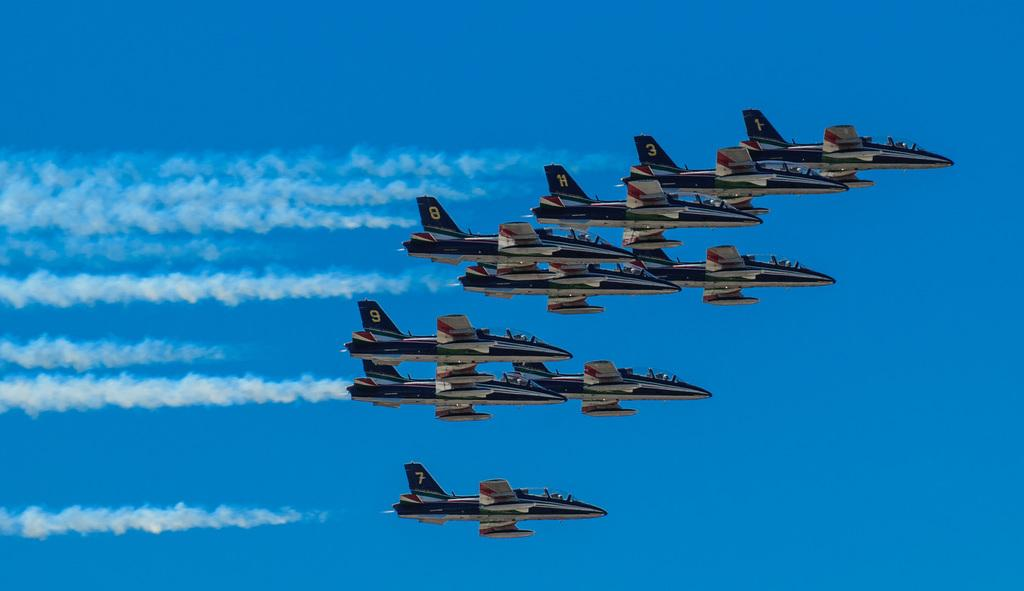What type of vehicles are in the image? There are jet planes in the image. What can be seen coming from the jet planes? There is smoke visible in the image. What color is the background of the image? The background of the image is blue. What type of pie is being served by the maid in the image? There is no maid or pie present in the image. 